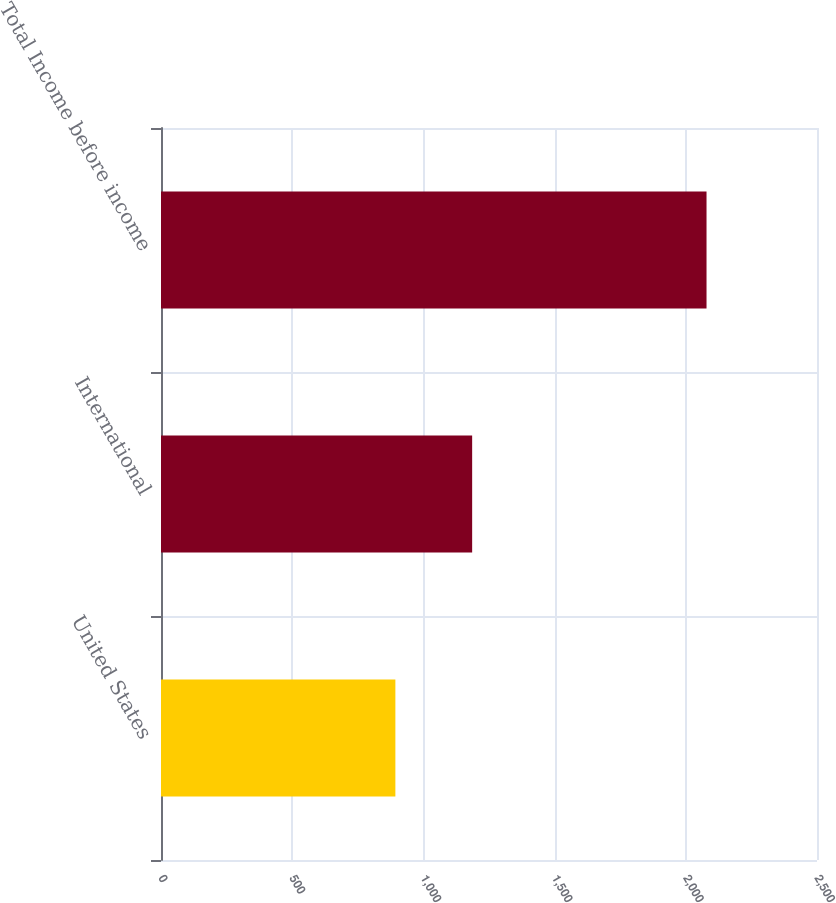Convert chart to OTSL. <chart><loc_0><loc_0><loc_500><loc_500><bar_chart><fcel>United States<fcel>International<fcel>Total Income before income<nl><fcel>893.2<fcel>1185.8<fcel>2079<nl></chart> 